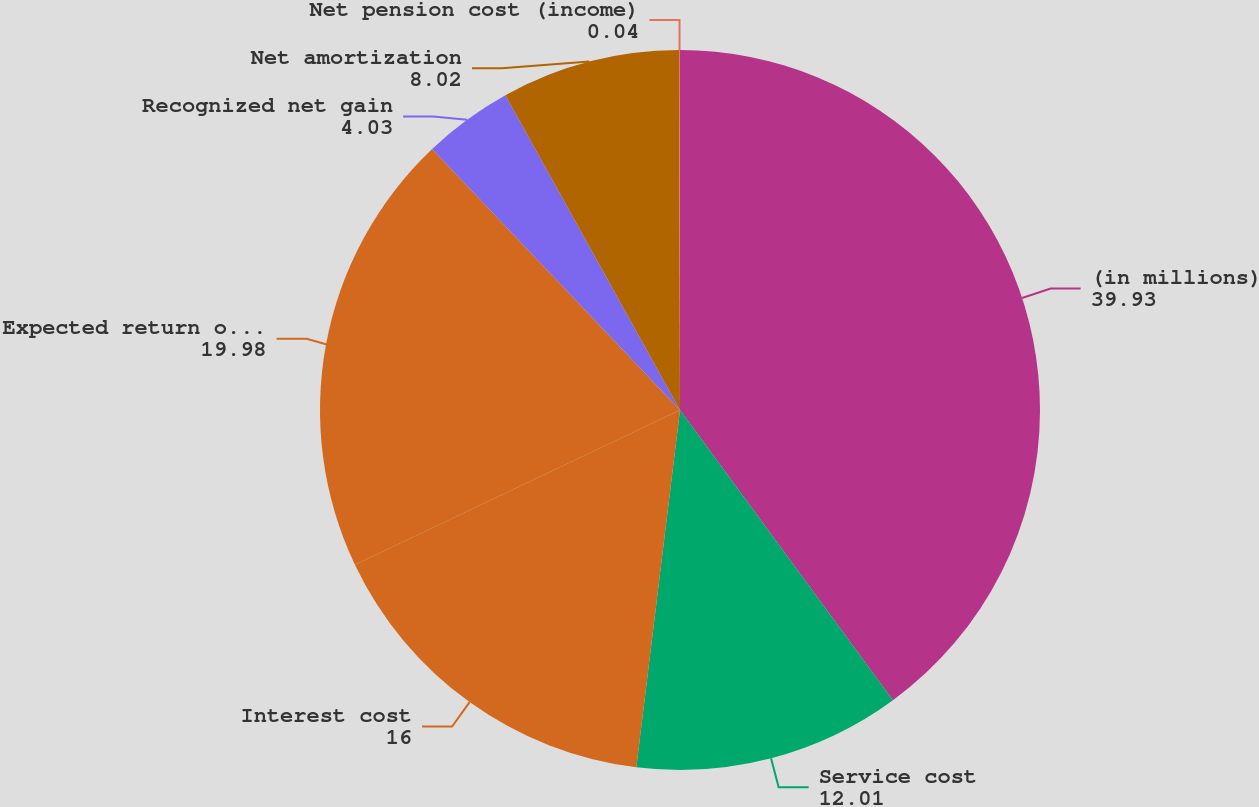Convert chart. <chart><loc_0><loc_0><loc_500><loc_500><pie_chart><fcel>(in millions)<fcel>Service cost<fcel>Interest cost<fcel>Expected return on plan assets<fcel>Recognized net gain<fcel>Net amortization<fcel>Net pension cost (income)<nl><fcel>39.93%<fcel>12.01%<fcel>16.0%<fcel>19.98%<fcel>4.03%<fcel>8.02%<fcel>0.04%<nl></chart> 